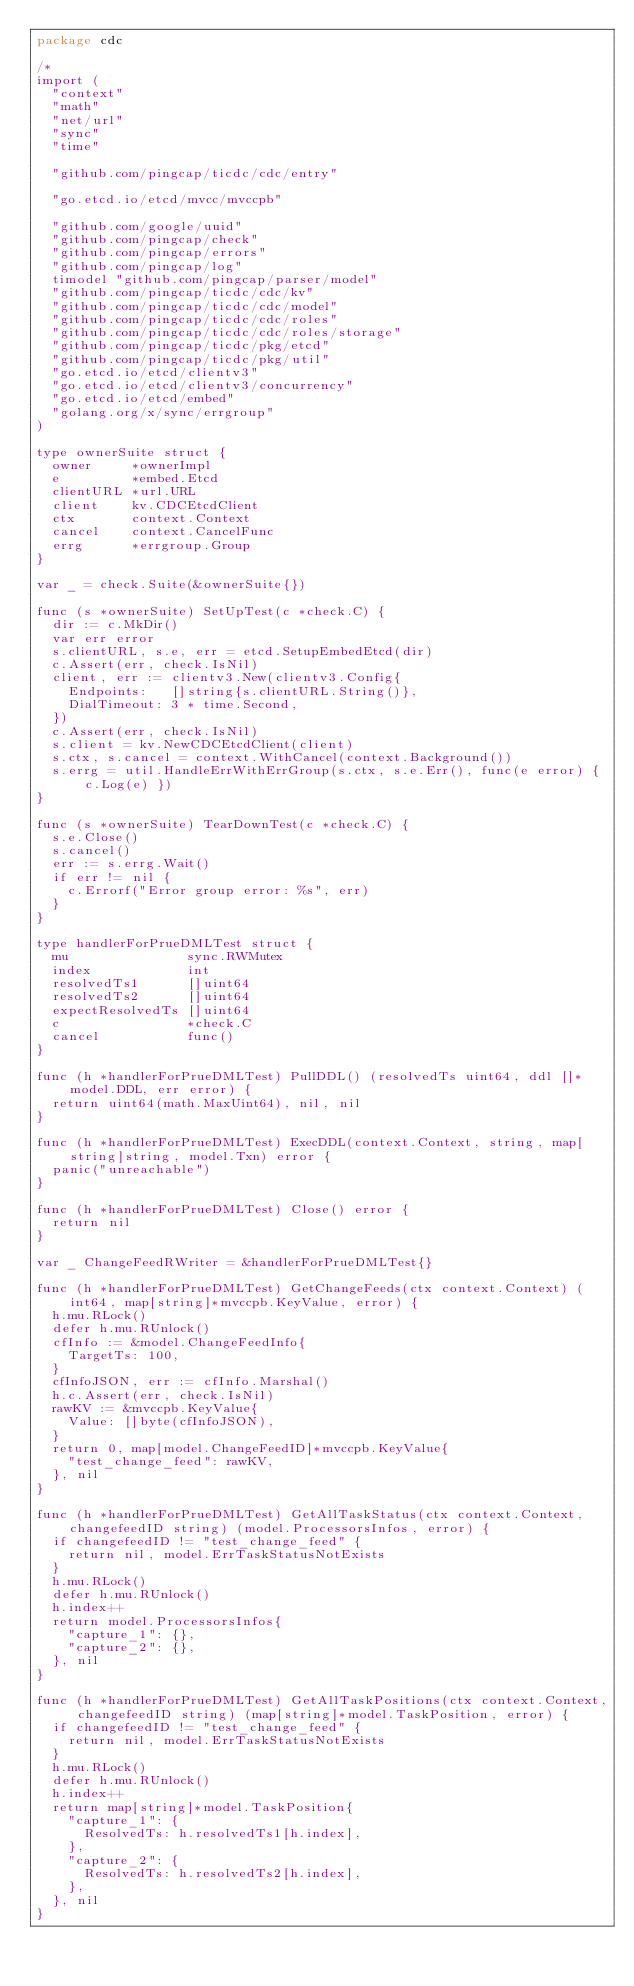Convert code to text. <code><loc_0><loc_0><loc_500><loc_500><_Go_>package cdc

/*
import (
	"context"
	"math"
	"net/url"
	"sync"
	"time"

	"github.com/pingcap/ticdc/cdc/entry"

	"go.etcd.io/etcd/mvcc/mvccpb"

	"github.com/google/uuid"
	"github.com/pingcap/check"
	"github.com/pingcap/errors"
	"github.com/pingcap/log"
	timodel "github.com/pingcap/parser/model"
	"github.com/pingcap/ticdc/cdc/kv"
	"github.com/pingcap/ticdc/cdc/model"
	"github.com/pingcap/ticdc/cdc/roles"
	"github.com/pingcap/ticdc/cdc/roles/storage"
	"github.com/pingcap/ticdc/pkg/etcd"
	"github.com/pingcap/ticdc/pkg/util"
	"go.etcd.io/etcd/clientv3"
	"go.etcd.io/etcd/clientv3/concurrency"
	"go.etcd.io/etcd/embed"
	"golang.org/x/sync/errgroup"
)

type ownerSuite struct {
	owner     *ownerImpl
	e         *embed.Etcd
	clientURL *url.URL
	client    kv.CDCEtcdClient
	ctx       context.Context
	cancel    context.CancelFunc
	errg      *errgroup.Group
}

var _ = check.Suite(&ownerSuite{})

func (s *ownerSuite) SetUpTest(c *check.C) {
	dir := c.MkDir()
	var err error
	s.clientURL, s.e, err = etcd.SetupEmbedEtcd(dir)
	c.Assert(err, check.IsNil)
	client, err := clientv3.New(clientv3.Config{
		Endpoints:   []string{s.clientURL.String()},
		DialTimeout: 3 * time.Second,
	})
	c.Assert(err, check.IsNil)
	s.client = kv.NewCDCEtcdClient(client)
	s.ctx, s.cancel = context.WithCancel(context.Background())
	s.errg = util.HandleErrWithErrGroup(s.ctx, s.e.Err(), func(e error) { c.Log(e) })
}

func (s *ownerSuite) TearDownTest(c *check.C) {
	s.e.Close()
	s.cancel()
	err := s.errg.Wait()
	if err != nil {
		c.Errorf("Error group error: %s", err)
	}
}

type handlerForPrueDMLTest struct {
	mu               sync.RWMutex
	index            int
	resolvedTs1      []uint64
	resolvedTs2      []uint64
	expectResolvedTs []uint64
	c                *check.C
	cancel           func()
}

func (h *handlerForPrueDMLTest) PullDDL() (resolvedTs uint64, ddl []*model.DDL, err error) {
	return uint64(math.MaxUint64), nil, nil
}

func (h *handlerForPrueDMLTest) ExecDDL(context.Context, string, map[string]string, model.Txn) error {
	panic("unreachable")
}

func (h *handlerForPrueDMLTest) Close() error {
	return nil
}

var _ ChangeFeedRWriter = &handlerForPrueDMLTest{}

func (h *handlerForPrueDMLTest) GetChangeFeeds(ctx context.Context) (int64, map[string]*mvccpb.KeyValue, error) {
	h.mu.RLock()
	defer h.mu.RUnlock()
	cfInfo := &model.ChangeFeedInfo{
		TargetTs: 100,
	}
	cfInfoJSON, err := cfInfo.Marshal()
	h.c.Assert(err, check.IsNil)
	rawKV := &mvccpb.KeyValue{
		Value: []byte(cfInfoJSON),
	}
	return 0, map[model.ChangeFeedID]*mvccpb.KeyValue{
		"test_change_feed": rawKV,
	}, nil
}

func (h *handlerForPrueDMLTest) GetAllTaskStatus(ctx context.Context, changefeedID string) (model.ProcessorsInfos, error) {
	if changefeedID != "test_change_feed" {
		return nil, model.ErrTaskStatusNotExists
	}
	h.mu.RLock()
	defer h.mu.RUnlock()
	h.index++
	return model.ProcessorsInfos{
		"capture_1": {},
		"capture_2": {},
	}, nil
}

func (h *handlerForPrueDMLTest) GetAllTaskPositions(ctx context.Context, changefeedID string) (map[string]*model.TaskPosition, error) {
	if changefeedID != "test_change_feed" {
		return nil, model.ErrTaskStatusNotExists
	}
	h.mu.RLock()
	defer h.mu.RUnlock()
	h.index++
	return map[string]*model.TaskPosition{
		"capture_1": {
			ResolvedTs: h.resolvedTs1[h.index],
		},
		"capture_2": {
			ResolvedTs: h.resolvedTs2[h.index],
		},
	}, nil
}
</code> 